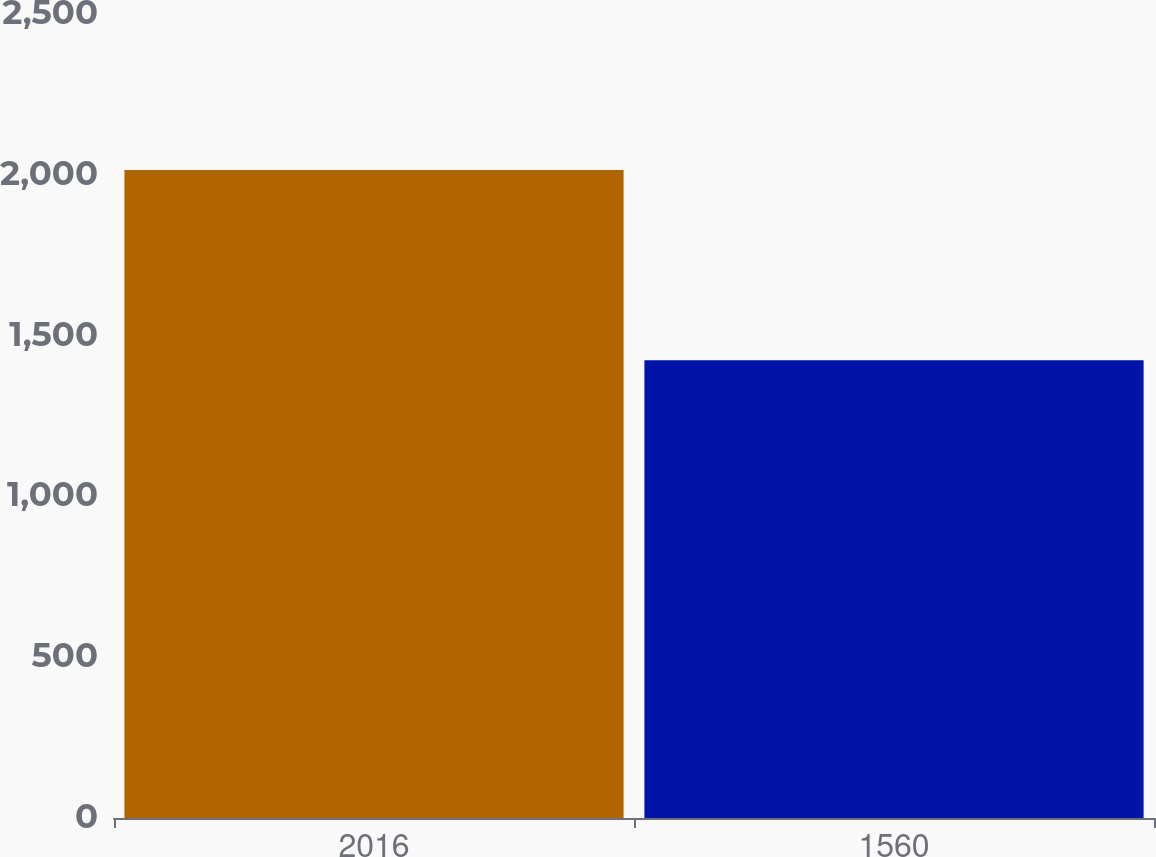Convert chart. <chart><loc_0><loc_0><loc_500><loc_500><bar_chart><fcel>2016<fcel>1560<nl><fcel>2015<fcel>1423<nl></chart> 